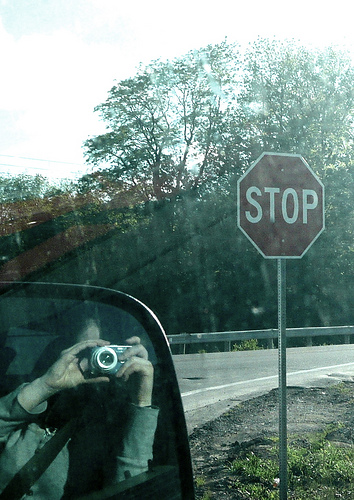Read and extract the text from this image. STOP 